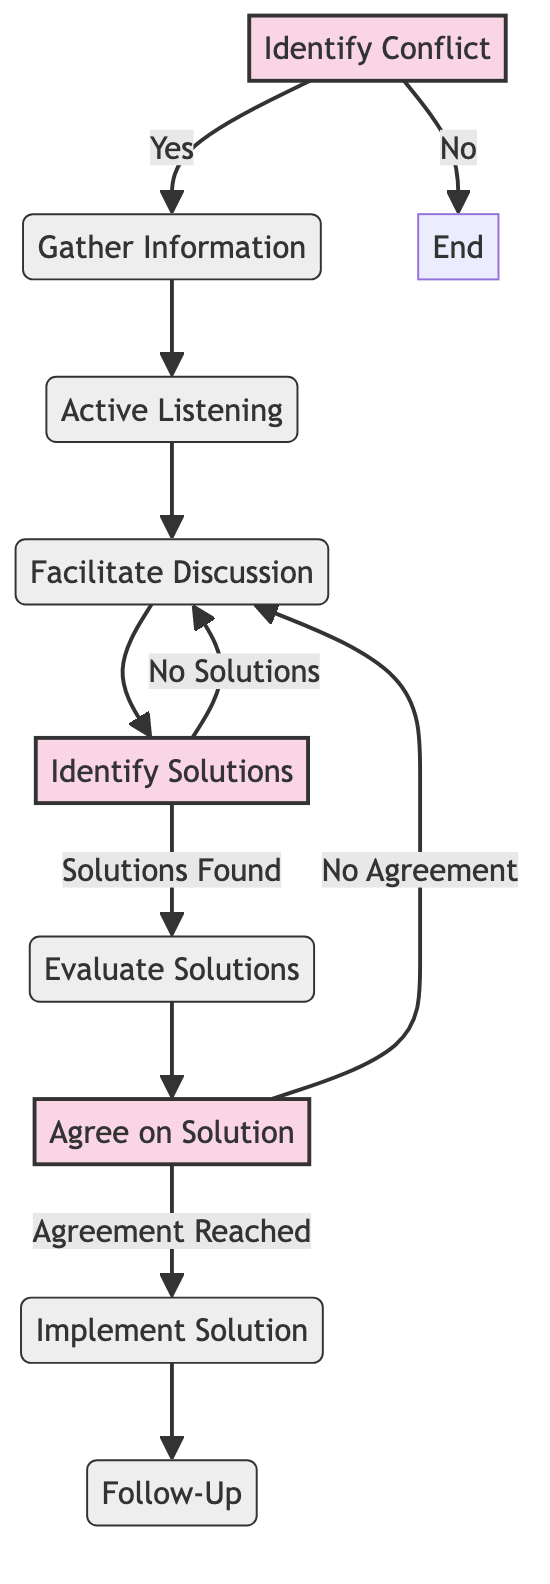What is the first step in handling conflicts during meetings? The first step is to "Identify Conflict," which involves recognizing and acknowledging that a conflict exists during the meeting.
Answer: Identify Conflict How many process nodes are there in the diagram? The diagram contains five process nodes: Gather Information, Active Listening, Facilitate Discussion, Evaluate Solutions, and Follow-Up.
Answer: Five What happens if no solutions are found after brainstorming? If no solutions are found, the flow indicates that the process returns to "Facilitate Discussion," allowing further discussions among the conflicting parties.
Answer: Facilitate Discussion What follows after the agreement on a solution is reached? Once an agreement on the solution is reached, the next step is to "Implement Solution," where the agreed-upon solution is put into action.
Answer: Implement Solution What is the final step in the conflict resolution process? The final step is "Follow-Up," which involves reviewing the situation in subsequent meetings to ensure that the conflict has been fully resolved.
Answer: Follow-Up What decision comes after evaluating solutions? After evaluating solutions, the decision is made to either agree on a solution or indicate that no agreement has been reached and continue discussions.
Answer: Agree on Solution What is the next action if there is no agreement after proposing solutions? If there is no agreement, the flow directs back to "Facilitate Discussion" to continue dialogue among the parties involved in the conflict.
Answer: Facilitate Discussion How many decision nodes are present in the flowchart? There are three decision nodes in the flowchart: Identify Solutions, Agree on Solution, and the conditional paths they create regarding solutions and agreements.
Answer: Three 